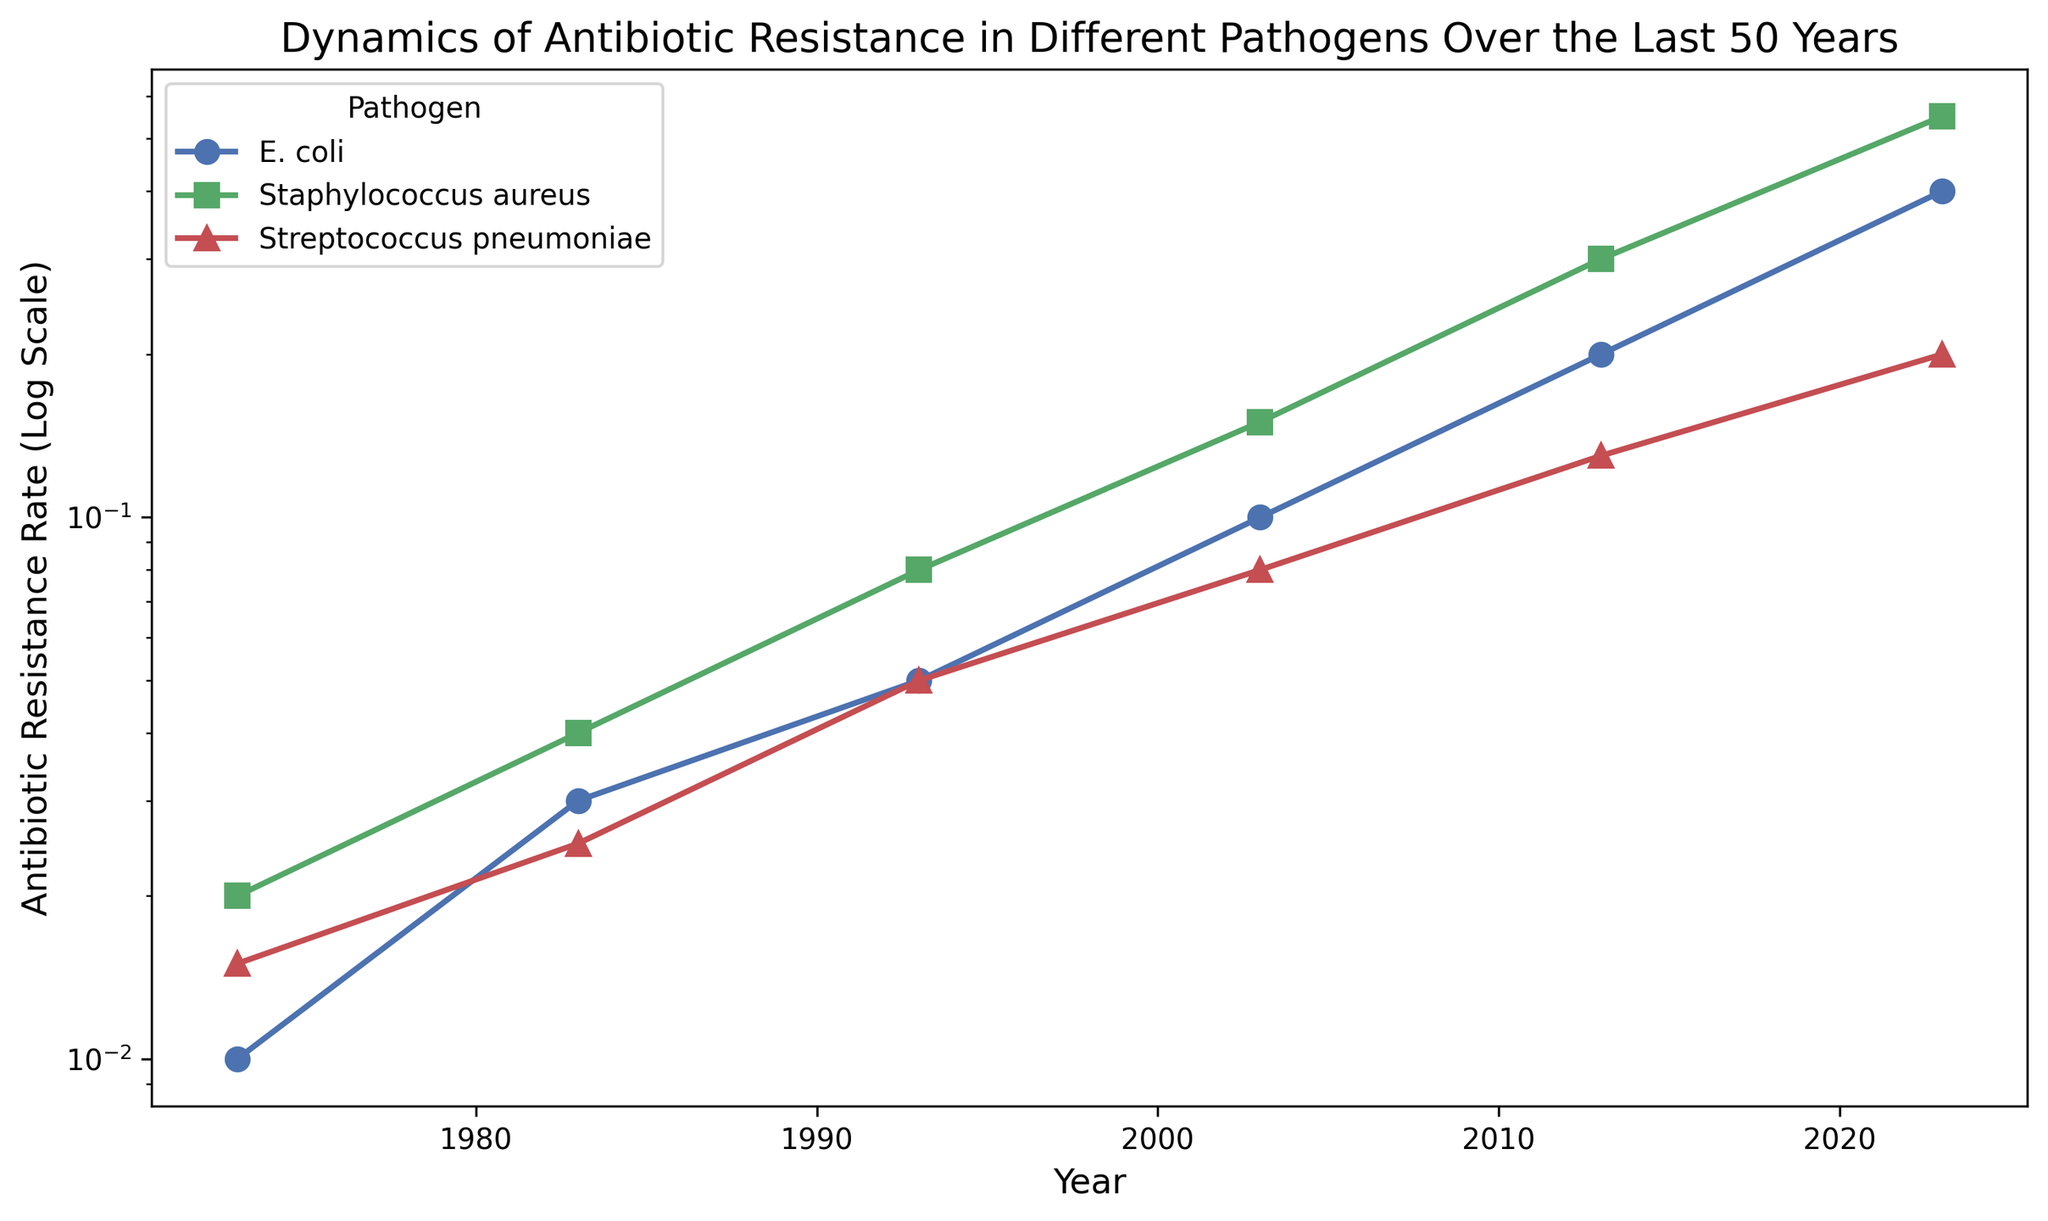How does the antibiotic resistance rate of E. coli in 1973 compare to that in 2023? Look at the data points for E. coli in 1973 and 2023. In 1973, the rate is 0.01 and in 2023, it is 0.4. To compare, you see that the rate has increased from 0.01 to 0.4.
Answer: The rate in 2023 is 0.39 higher than in 1973 Which pathogen has the highest antibiotic resistance rate in 2023? Observe the data points for all pathogens in 2023 and compare their values. E. coli has 0.4, Staphylococcus aureus has 0.55, and Streptococcus pneumoniae has 0.2. The highest value is 0.55 for Staphylococcus aureus.
Answer: Staphylococcus aureus Has the antibiotic resistance rate of Streptococcus pneumoniae increased or decreased from 2003 to 2013? Check the rates of Streptococcus pneumoniae in 2003 and 2013. In 2003, the rate is 0.08 and in 2013, it is 0.13. The rate has increased from 0.08 to 0.13.
Answer: Increased Calculate the average antibiotic resistance rate of Staphylococcus aureus over the entire period. Sum the rates of Staphylococcus aureus from each year and divide by the number of years. The rates are 0.02, 0.04, 0.08, 0.15, 0.3, and 0.55. Sum = 1.14. Dividing by 6 gives 1.14/6 ≈ 0.19.
Answer: 0.19 Which pathogen has the fastest growth rate in antibiotic resistance from 1973 to 2023? Calculate the rate of increase for each pathogen by subtracting the 1973 rate from the 2023 rate. E. coli: 0.4 - 0.01 = 0.39; Staphylococcus aureus: 0.55 - 0.02 = 0.53; Streptococcus pneumoniae: 0.2 - 0.015 = 0.185. Staphylococcus aureus has the highest increase.
Answer: Staphylococcus aureus By what factor has the antibiotic resistance rate of E. coli increased from 1973 to 2023? Divide the 2023 rate by the 1973 rate for E. coli. The rates are 0.4 and 0.01, respectively. So, 0.4 / 0.01 = 40.
Answer: 40 Compare the antibiotic resistance rate of Staphylococcus aureus to Streptococcus pneumoniae in 1983. Look at the 1983 values for both pathogens. Staphylococcus aureus has a rate of 0.04 and Streptococcus pneumoniae has a rate of 0.025. 0.04 is greater than 0.025.
Answer: Staphylococcus aureus has a higher rate Which year shows the largest increase in antibiotic resistance rate for E. coli compared to the previous decade? Calculate the difference between each consecutive decade for E. coli: 
1973-1983: 0.03 - 0.01 = 0.02,
1983-1993: 0.05 - 0.03 = 0.02,
1993-2003: 0.1 - 0.05 = 0.05,
2003-2013: 0.2 - 0.1 = 0.1,
2013-2023: 0.4 - 0.2 = 0.2; 
The largest increase is 0.2 between 2013 to 2023.
Answer: 2013-2023 What is the trend in the antibiotic resistance rate of all pathogens over the last 50 years? Observe all the data points over the years for each pathogen. All pathogens show a positive trend, indicating an increase in antibiotic resistance over time.
Answer: Increasing trend 